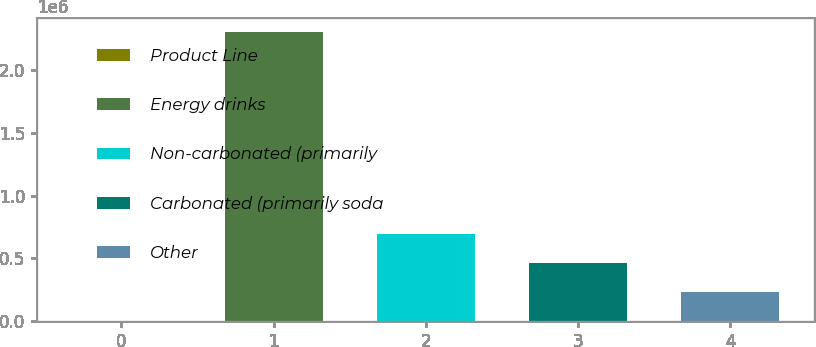Convert chart to OTSL. <chart><loc_0><loc_0><loc_500><loc_500><bar_chart><fcel>Product Line<fcel>Energy drinks<fcel>Non-carbonated (primarily<fcel>Carbonated (primarily soda<fcel>Other<nl><fcel>2014<fcel>2.30222e+06<fcel>692077<fcel>462056<fcel>232035<nl></chart> 